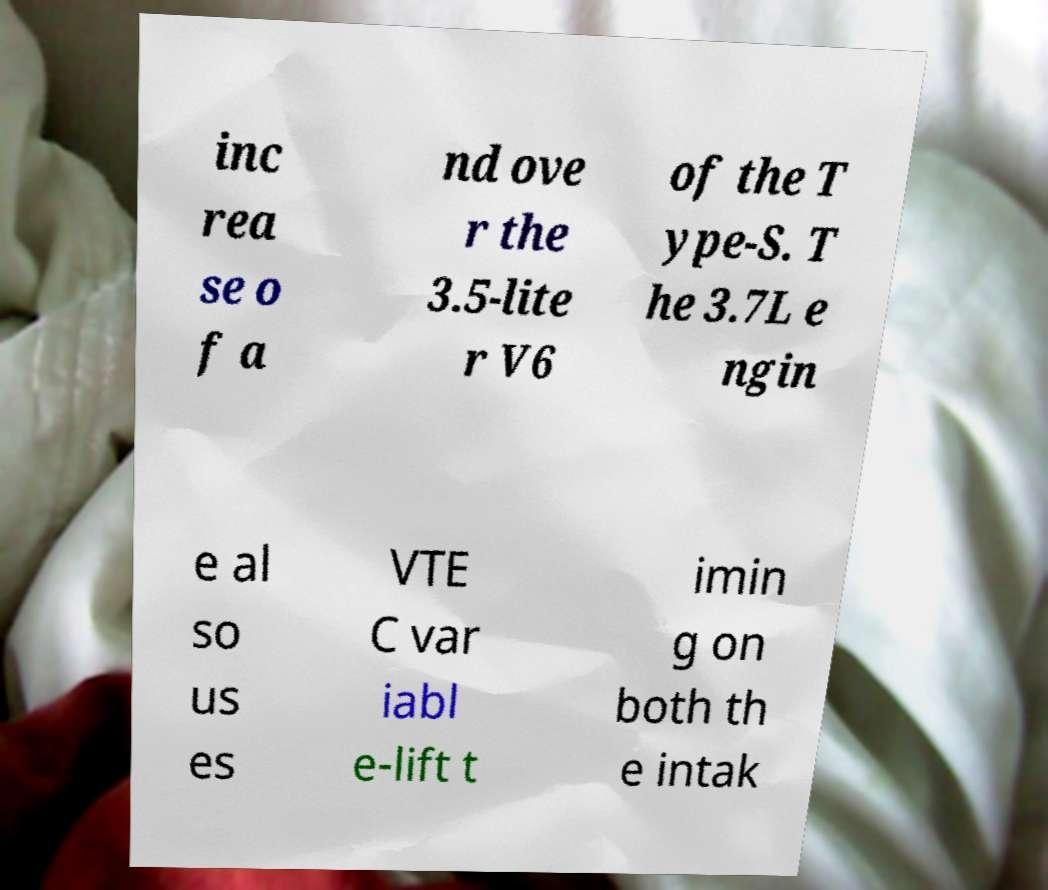Could you assist in decoding the text presented in this image and type it out clearly? inc rea se o f a nd ove r the 3.5-lite r V6 of the T ype-S. T he 3.7L e ngin e al so us es VTE C var iabl e-lift t imin g on both th e intak 